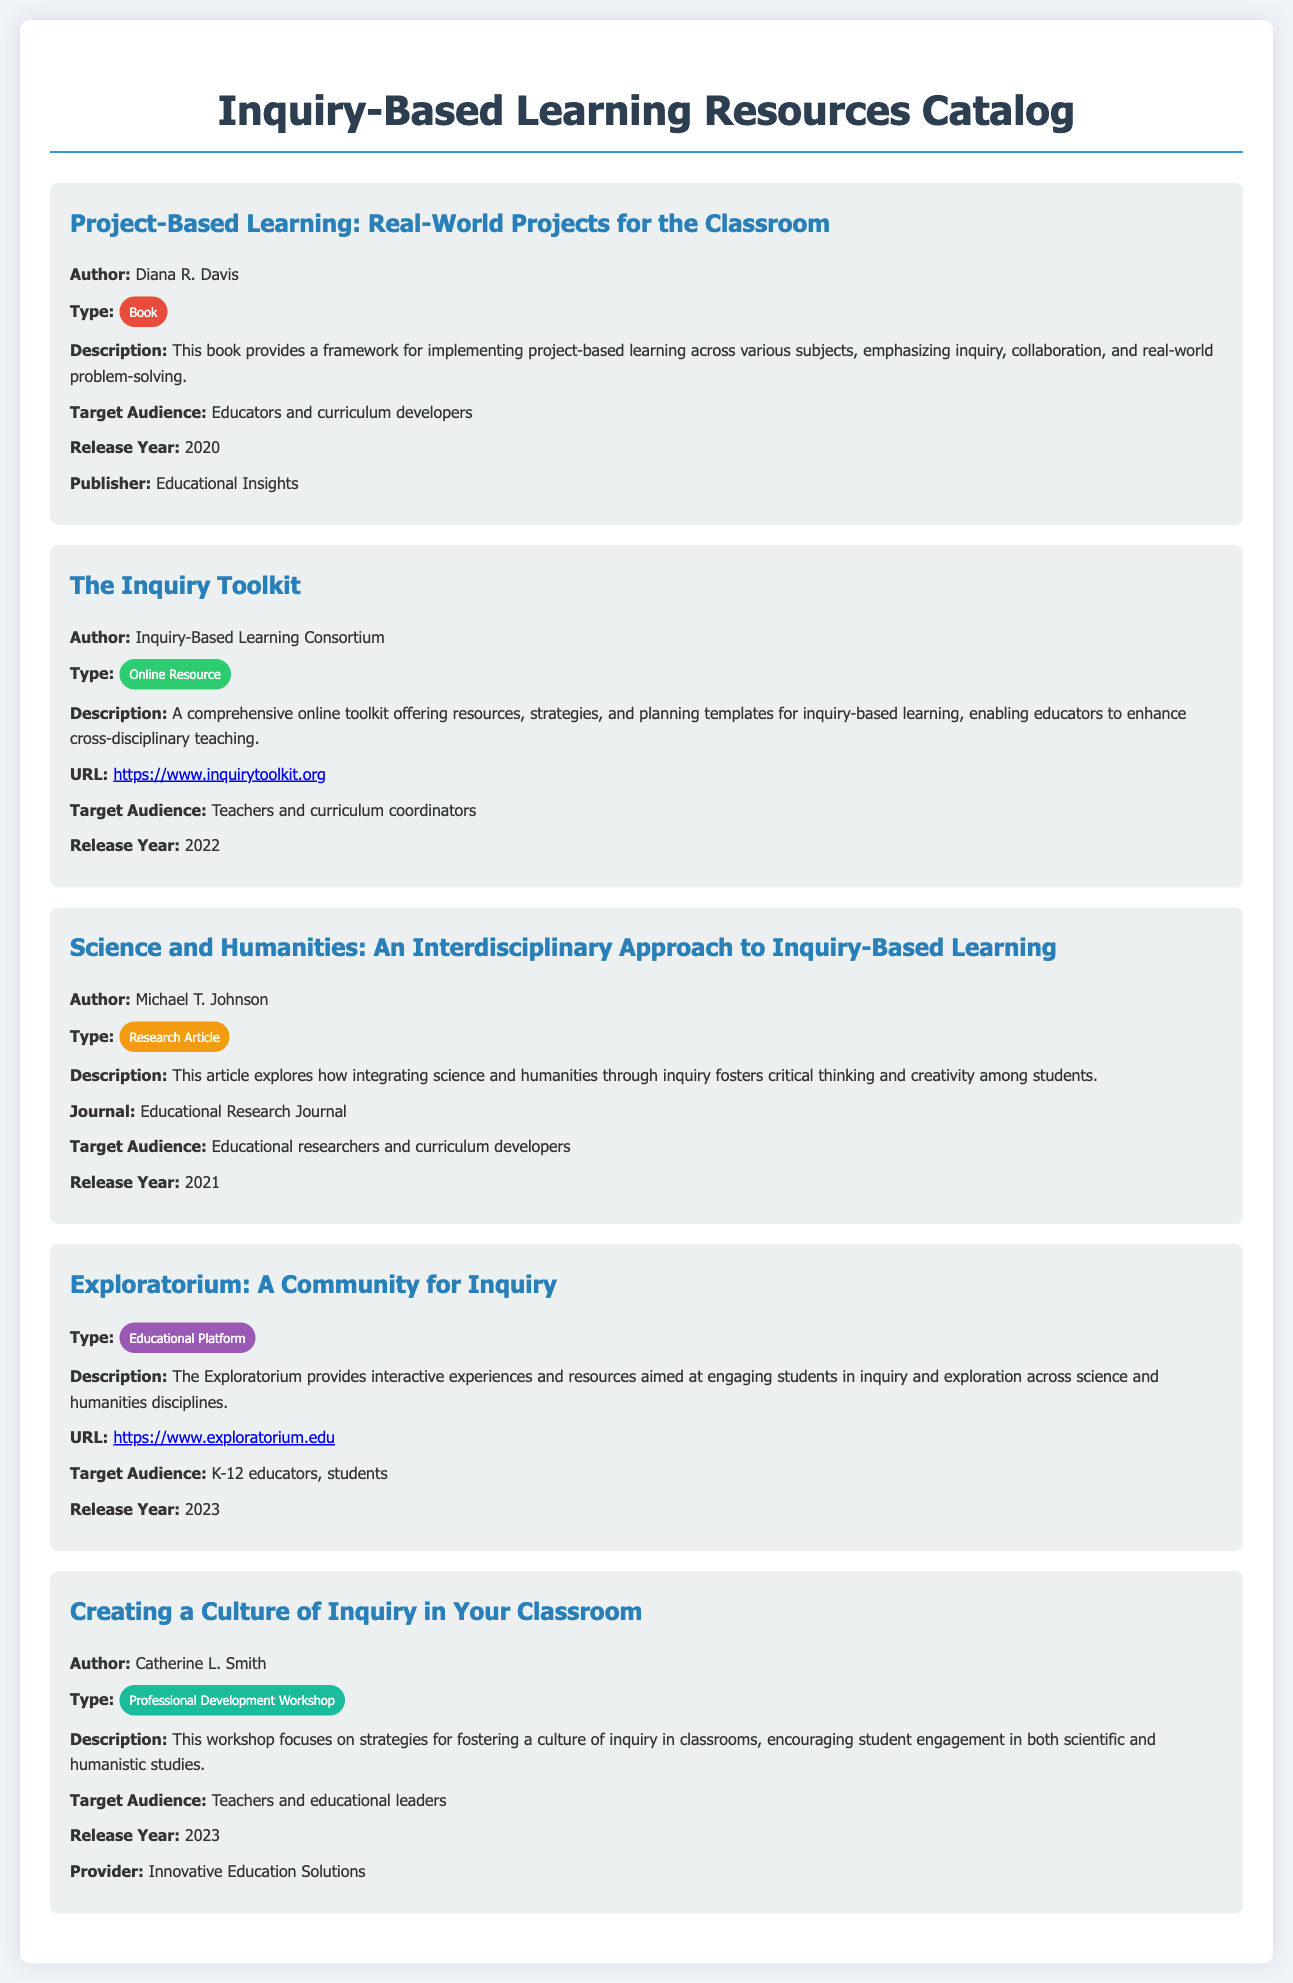What is the title of the first resource? The first resource is titled "Project-Based Learning: Real-World Projects for the Classroom," as listed in the document.
Answer: Project-Based Learning: Real-World Projects for the Classroom Who is the author of "The Inquiry Toolkit"? The author of "The Inquiry Toolkit" is the Inquiry-Based Learning Consortium, as mentioned in the document.
Answer: Inquiry-Based Learning Consortium What type of resource is "Science and Humanities: An Interdisciplinary Approach to Inquiry-Based Learning"? The document specifies that it is a research article, categorizing it accordingly.
Answer: Research Article In what year was the "Exploratorium: A Community for Inquiry" released? The release year for "Exploratorium: A Community for Inquiry" is found in the document as 2023.
Answer: 2023 Who is the target audience for "Creating a Culture of Inquiry in Your Classroom"? The document indicates that the target audience for this workshop includes teachers and educational leaders.
Answer: Teachers and educational leaders What is the primary focus of the book by Diana R. Davis? The book emphasizes inquiry, collaboration, and real-world problem-solving as its main focus, as stated in the document.
Answer: Inquiry, collaboration, and real-world problem-solving What type of educational resource is the "Inquiry Toolkit"? The type of resource is clearly defined as an online resource within the document.
Answer: Online Resource 